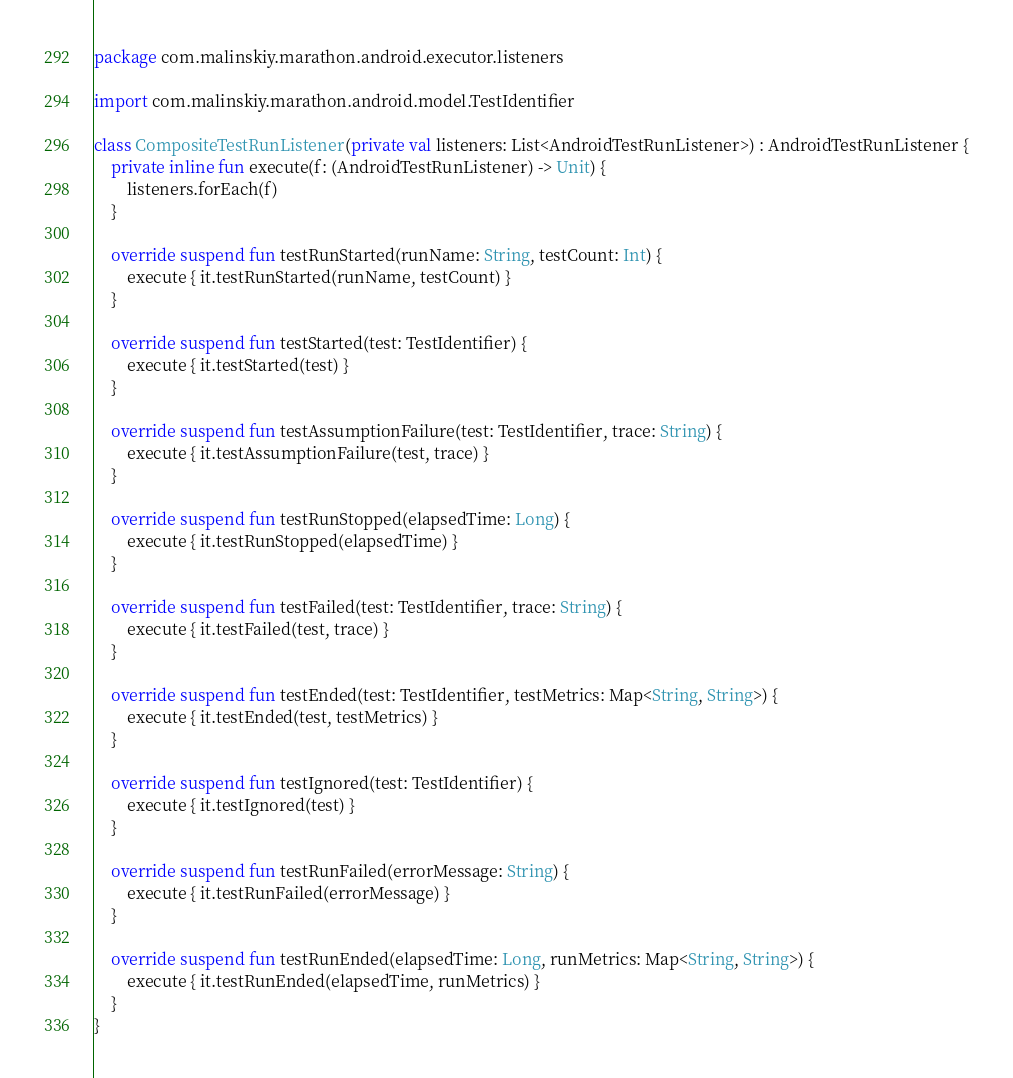Convert code to text. <code><loc_0><loc_0><loc_500><loc_500><_Kotlin_>package com.malinskiy.marathon.android.executor.listeners

import com.malinskiy.marathon.android.model.TestIdentifier

class CompositeTestRunListener(private val listeners: List<AndroidTestRunListener>) : AndroidTestRunListener {
    private inline fun execute(f: (AndroidTestRunListener) -> Unit) {
        listeners.forEach(f)
    }

    override suspend fun testRunStarted(runName: String, testCount: Int) {
        execute { it.testRunStarted(runName, testCount) }
    }

    override suspend fun testStarted(test: TestIdentifier) {
        execute { it.testStarted(test) }
    }

    override suspend fun testAssumptionFailure(test: TestIdentifier, trace: String) {
        execute { it.testAssumptionFailure(test, trace) }
    }

    override suspend fun testRunStopped(elapsedTime: Long) {
        execute { it.testRunStopped(elapsedTime) }
    }

    override suspend fun testFailed(test: TestIdentifier, trace: String) {
        execute { it.testFailed(test, trace) }
    }

    override suspend fun testEnded(test: TestIdentifier, testMetrics: Map<String, String>) {
        execute { it.testEnded(test, testMetrics) }
    }

    override suspend fun testIgnored(test: TestIdentifier) {
        execute { it.testIgnored(test) }
    }

    override suspend fun testRunFailed(errorMessage: String) {
        execute { it.testRunFailed(errorMessage) }
    }

    override suspend fun testRunEnded(elapsedTime: Long, runMetrics: Map<String, String>) {
        execute { it.testRunEnded(elapsedTime, runMetrics) }
    }
}
</code> 